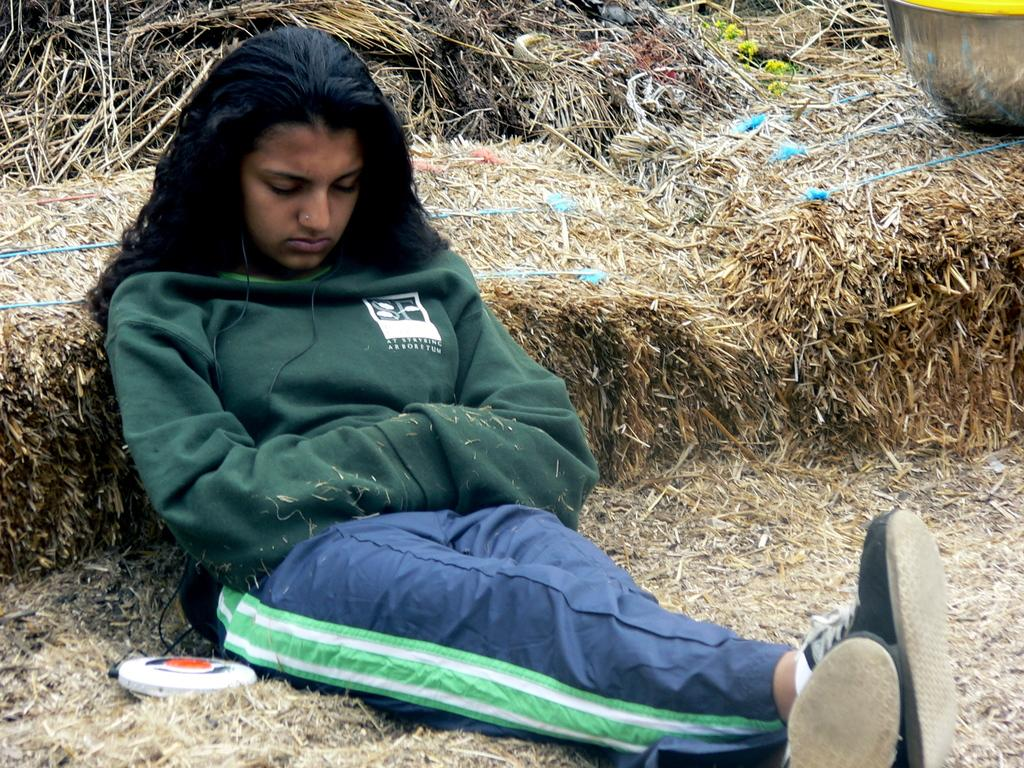Who is present in the image? There is a woman in the image. What is the woman doing in the image? The woman is sitting on the ground. What is the woman wearing in the image? The woman is wearing earphones. What can be seen in the background of the image? There is dry grass in the background of the image. What other objects can be seen in the image? There are other unspecified objects in the image. What type of egg is being crushed by the zephyr in the image? There is no egg or zephyr present in the image. 